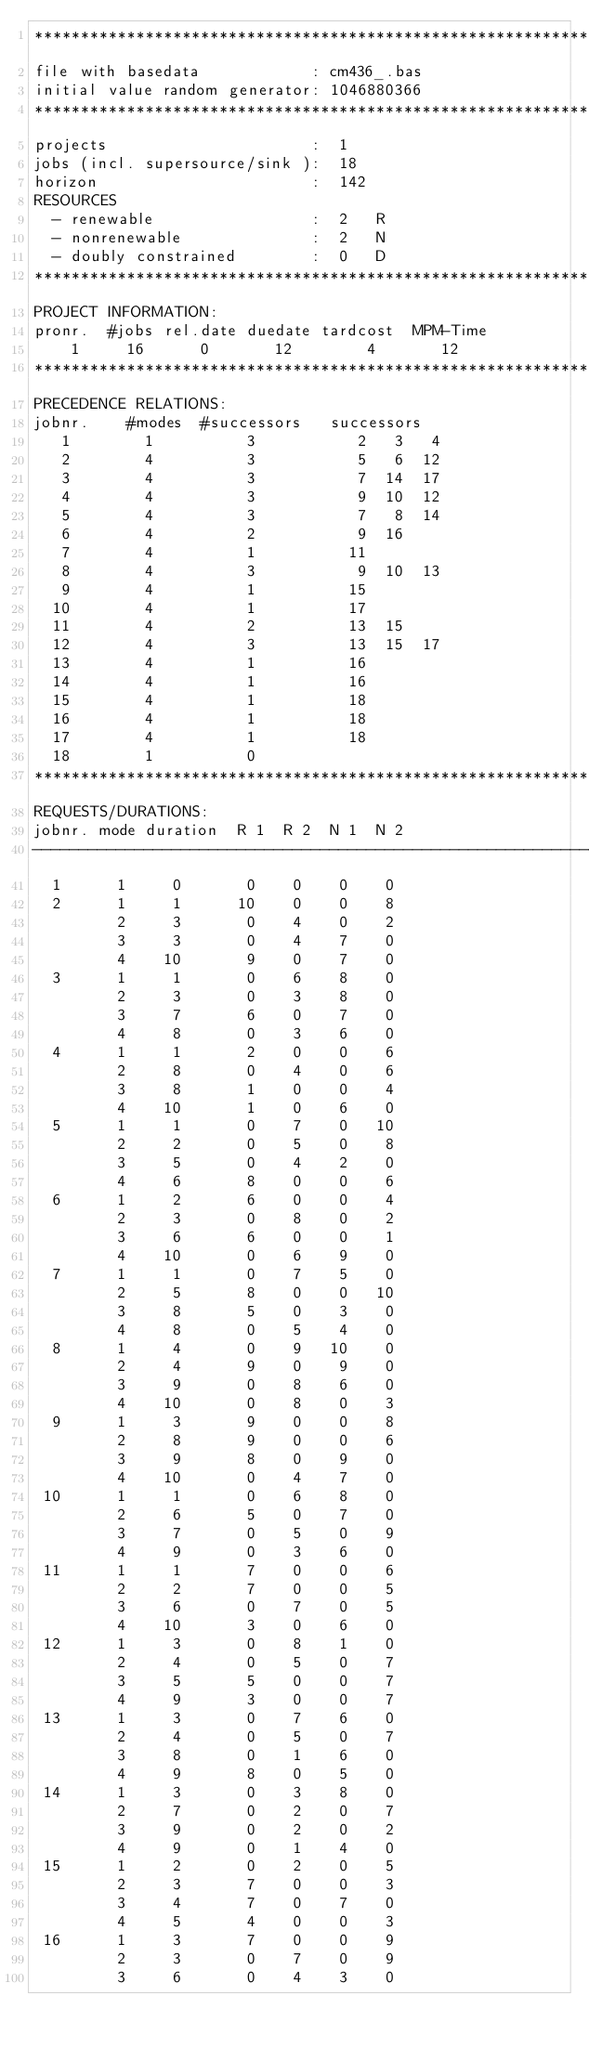<code> <loc_0><loc_0><loc_500><loc_500><_ObjectiveC_>************************************************************************
file with basedata            : cm436_.bas
initial value random generator: 1046880366
************************************************************************
projects                      :  1
jobs (incl. supersource/sink ):  18
horizon                       :  142
RESOURCES
  - renewable                 :  2   R
  - nonrenewable              :  2   N
  - doubly constrained        :  0   D
************************************************************************
PROJECT INFORMATION:
pronr.  #jobs rel.date duedate tardcost  MPM-Time
    1     16      0       12        4       12
************************************************************************
PRECEDENCE RELATIONS:
jobnr.    #modes  #successors   successors
   1        1          3           2   3   4
   2        4          3           5   6  12
   3        4          3           7  14  17
   4        4          3           9  10  12
   5        4          3           7   8  14
   6        4          2           9  16
   7        4          1          11
   8        4          3           9  10  13
   9        4          1          15
  10        4          1          17
  11        4          2          13  15
  12        4          3          13  15  17
  13        4          1          16
  14        4          1          16
  15        4          1          18
  16        4          1          18
  17        4          1          18
  18        1          0        
************************************************************************
REQUESTS/DURATIONS:
jobnr. mode duration  R 1  R 2  N 1  N 2
------------------------------------------------------------------------
  1      1     0       0    0    0    0
  2      1     1      10    0    0    8
         2     3       0    4    0    2
         3     3       0    4    7    0
         4    10       9    0    7    0
  3      1     1       0    6    8    0
         2     3       0    3    8    0
         3     7       6    0    7    0
         4     8       0    3    6    0
  4      1     1       2    0    0    6
         2     8       0    4    0    6
         3     8       1    0    0    4
         4    10       1    0    6    0
  5      1     1       0    7    0   10
         2     2       0    5    0    8
         3     5       0    4    2    0
         4     6       8    0    0    6
  6      1     2       6    0    0    4
         2     3       0    8    0    2
         3     6       6    0    0    1
         4    10       0    6    9    0
  7      1     1       0    7    5    0
         2     5       8    0    0   10
         3     8       5    0    3    0
         4     8       0    5    4    0
  8      1     4       0    9   10    0
         2     4       9    0    9    0
         3     9       0    8    6    0
         4    10       0    8    0    3
  9      1     3       9    0    0    8
         2     8       9    0    0    6
         3     9       8    0    9    0
         4    10       0    4    7    0
 10      1     1       0    6    8    0
         2     6       5    0    7    0
         3     7       0    5    0    9
         4     9       0    3    6    0
 11      1     1       7    0    0    6
         2     2       7    0    0    5
         3     6       0    7    0    5
         4    10       3    0    6    0
 12      1     3       0    8    1    0
         2     4       0    5    0    7
         3     5       5    0    0    7
         4     9       3    0    0    7
 13      1     3       0    7    6    0
         2     4       0    5    0    7
         3     8       0    1    6    0
         4     9       8    0    5    0
 14      1     3       0    3    8    0
         2     7       0    2    0    7
         3     9       0    2    0    2
         4     9       0    1    4    0
 15      1     2       0    2    0    5
         2     3       7    0    0    3
         3     4       7    0    7    0
         4     5       4    0    0    3
 16      1     3       7    0    0    9
         2     3       0    7    0    9
         3     6       0    4    3    0</code> 